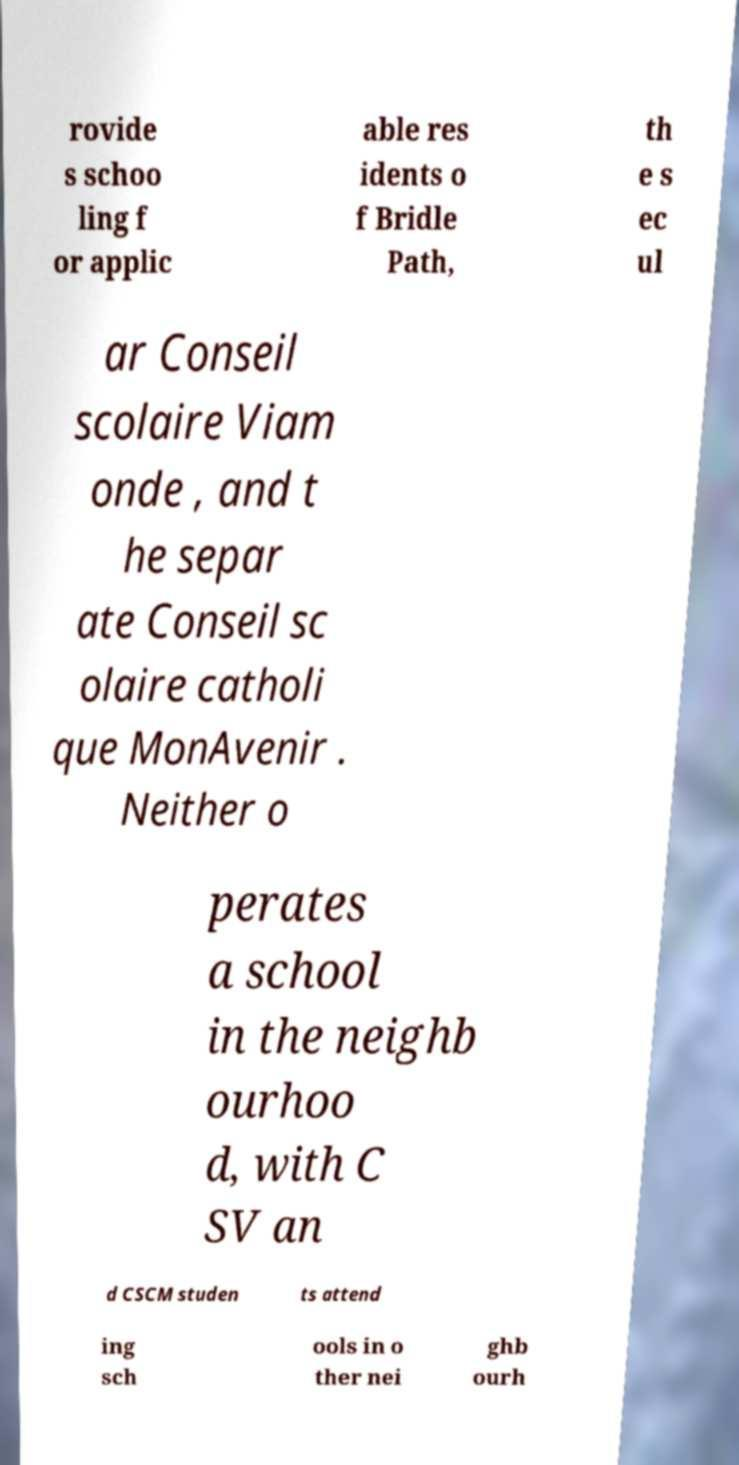Please identify and transcribe the text found in this image. rovide s schoo ling f or applic able res idents o f Bridle Path, th e s ec ul ar Conseil scolaire Viam onde , and t he separ ate Conseil sc olaire catholi que MonAvenir . Neither o perates a school in the neighb ourhoo d, with C SV an d CSCM studen ts attend ing sch ools in o ther nei ghb ourh 